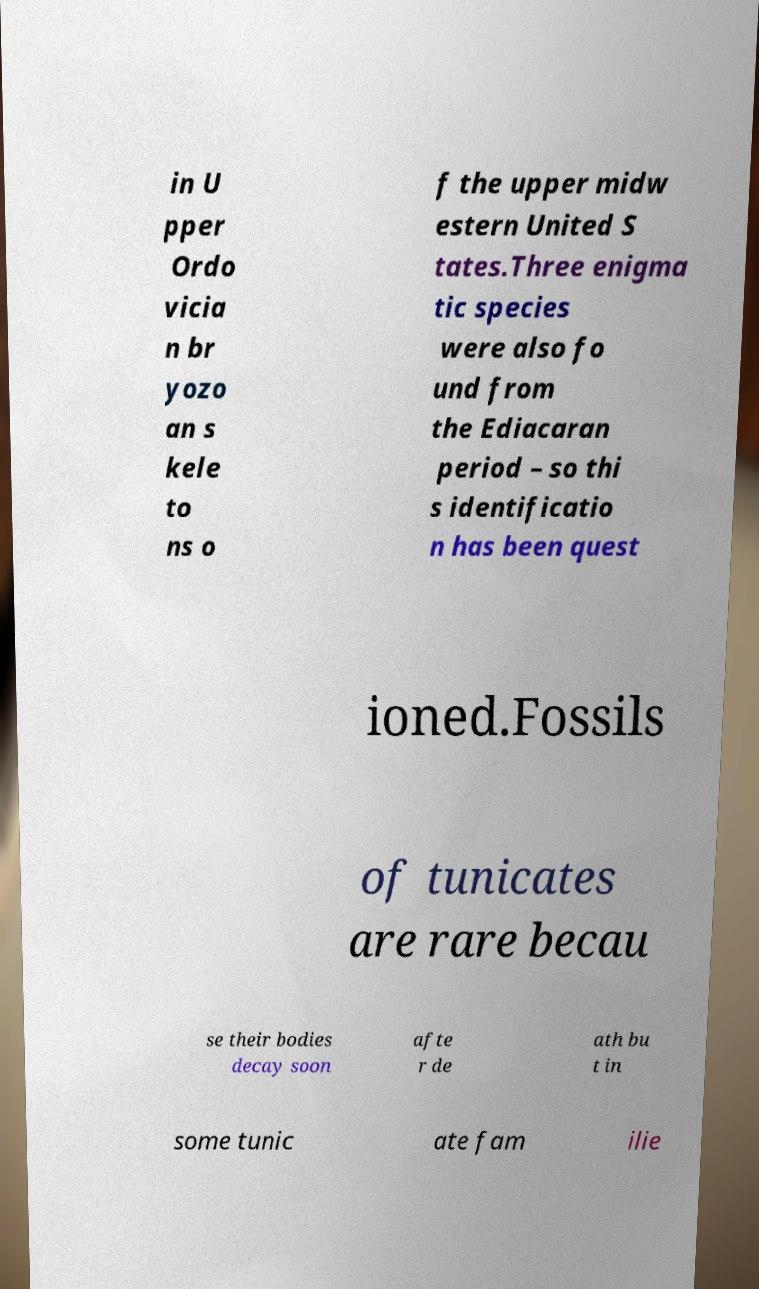Could you assist in decoding the text presented in this image and type it out clearly? in U pper Ordo vicia n br yozo an s kele to ns o f the upper midw estern United S tates.Three enigma tic species were also fo und from the Ediacaran period – so thi s identificatio n has been quest ioned.Fossils of tunicates are rare becau se their bodies decay soon afte r de ath bu t in some tunic ate fam ilie 